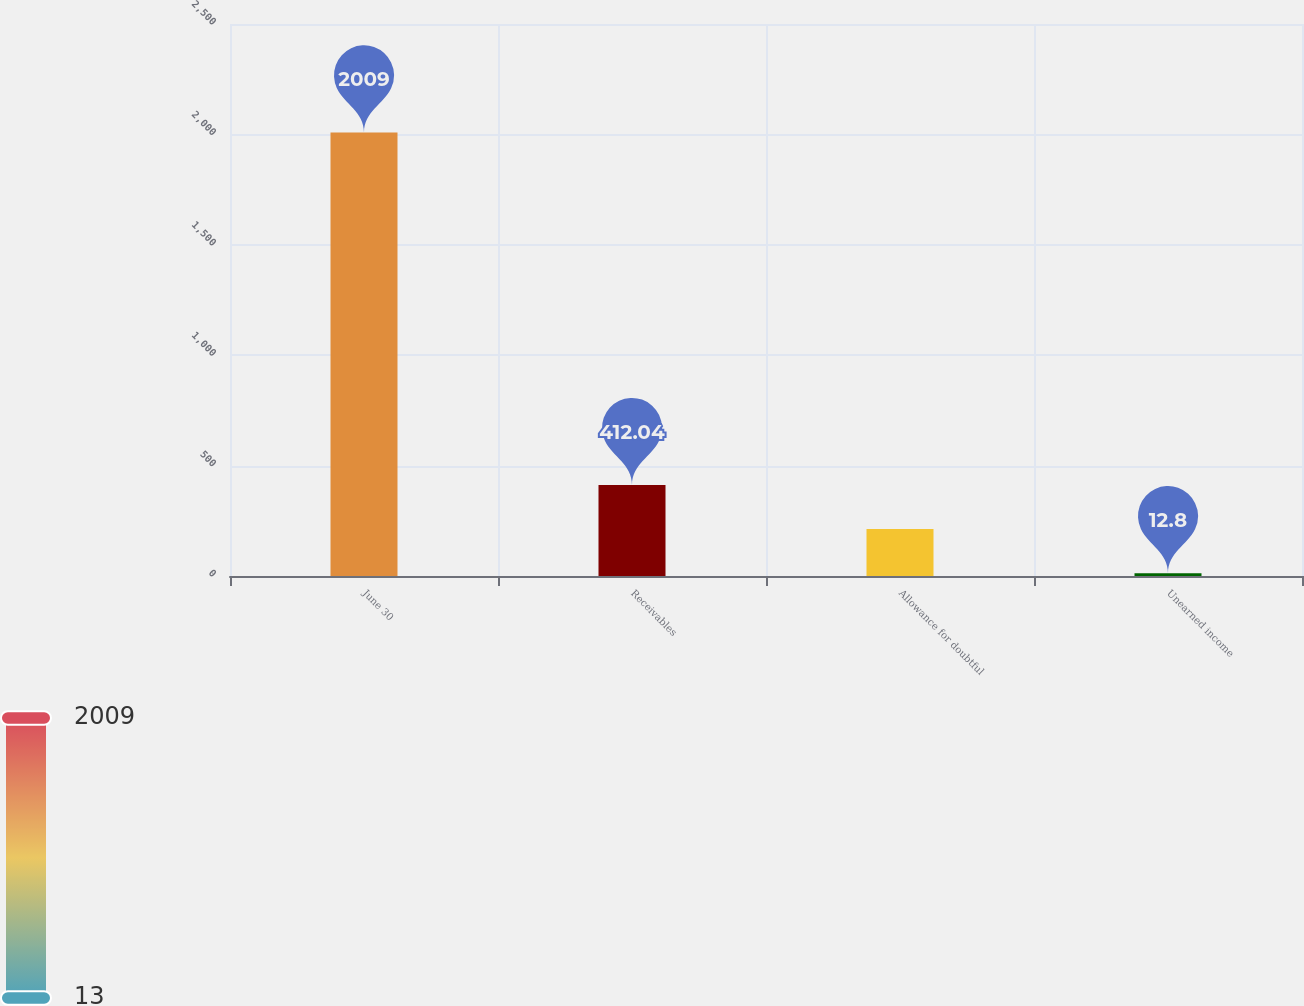Convert chart. <chart><loc_0><loc_0><loc_500><loc_500><bar_chart><fcel>June 30<fcel>Receivables<fcel>Allowance for doubtful<fcel>Unearned income<nl><fcel>2009<fcel>412.04<fcel>212.42<fcel>12.8<nl></chart> 